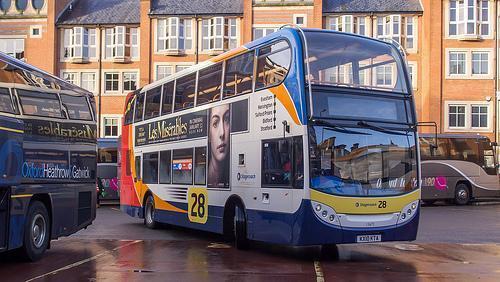How many buses are there?
Give a very brief answer. 4. 